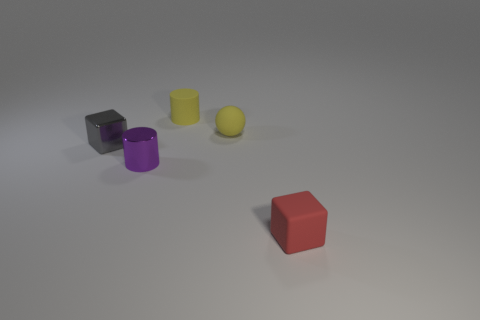Add 3 big blue matte cylinders. How many objects exist? 8 Subtract all balls. How many objects are left? 4 Subtract all gray rubber objects. Subtract all tiny purple metal things. How many objects are left? 4 Add 4 small yellow balls. How many small yellow balls are left? 5 Add 1 large red matte blocks. How many large red matte blocks exist? 1 Subtract 0 purple cubes. How many objects are left? 5 